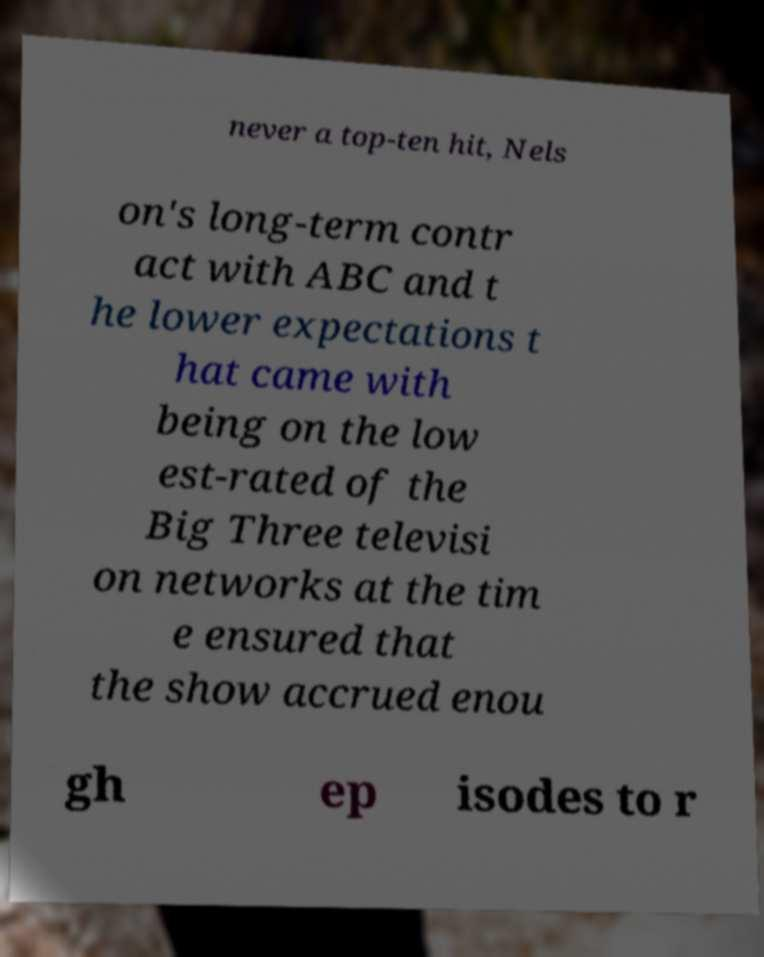What messages or text are displayed in this image? I need them in a readable, typed format. never a top-ten hit, Nels on's long-term contr act with ABC and t he lower expectations t hat came with being on the low est-rated of the Big Three televisi on networks at the tim e ensured that the show accrued enou gh ep isodes to r 